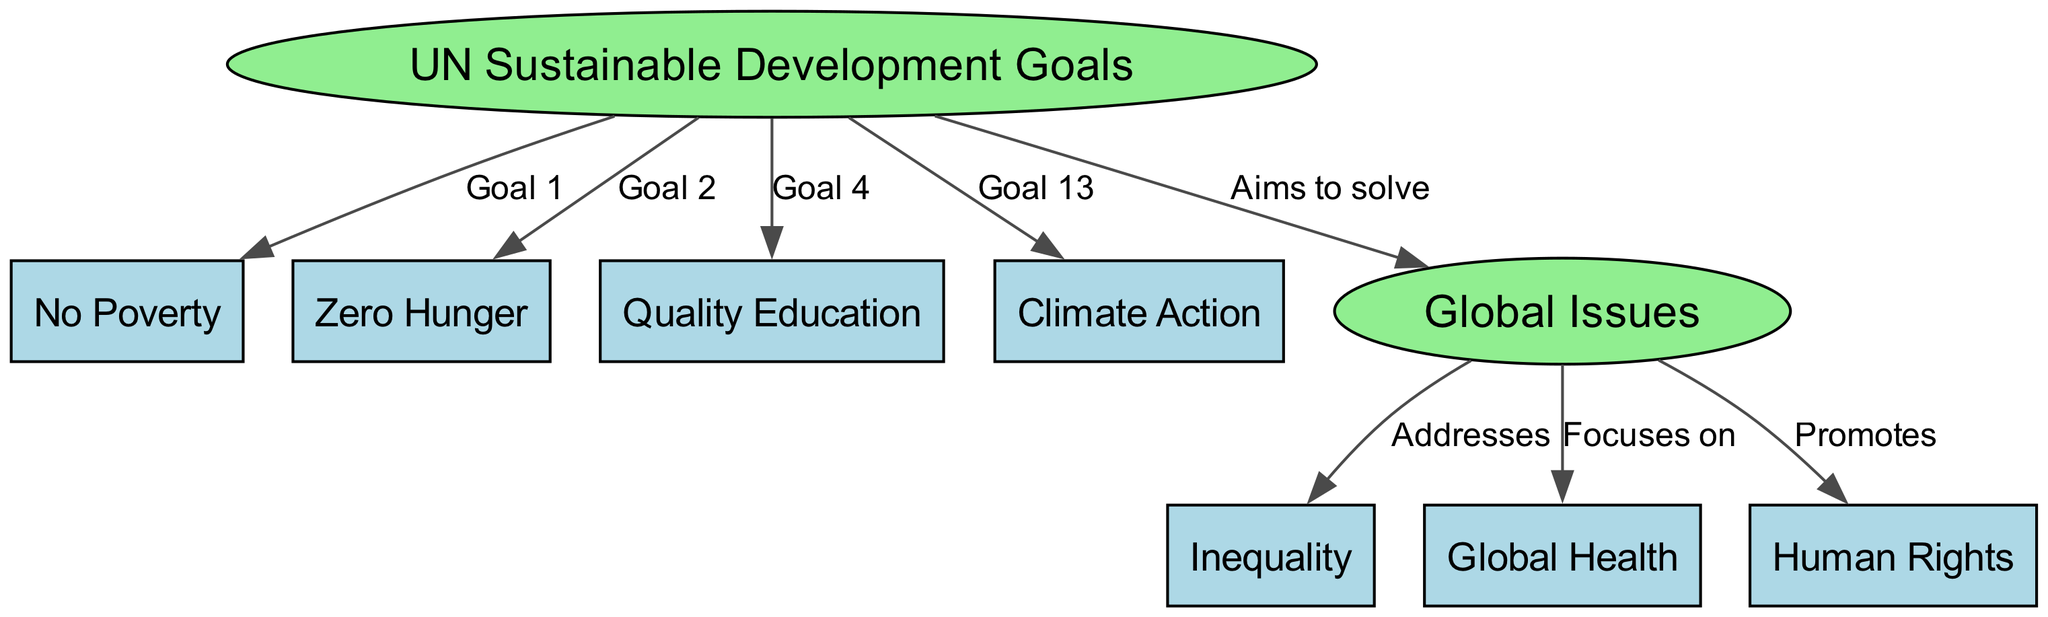What are the four main Sustainable Development Goals represented in the diagram? The diagram shows four specific Sustainable Development Goals: No Poverty, Zero Hunger, Quality Education, and Climate Action. These are found as distinct nodes directly connected to the UN Sustainable Development Goals node.
Answer: No Poverty, Zero Hunger, Quality Education, Climate Action How many edges connect the SDGs to specific goals? In the diagram, there are four edges connecting the SDGs node to specific goals, representing the relationships between the main goal and the four listed goals.
Answer: 4 Which global issue is addressed by the UN Sustainable Development Goals? The relationship between the SDGs and global issues is shown with an edge labeled "Aims to solve," indicating that they are intended to tackle various global issues like inequality, health, and human rights.
Answer: Inequality What is the label for the edge connecting global issues to health? The edge that connects the global issues node to the health node is labeled "Focuses on," which clearly indicates the relationship.
Answer: Focuses on How many total nodes are in the diagram? The diagram contains a total of eight nodes: four for the Sustainable Development Goals, one for global issues, and three for specific global issues (inequality, health, human rights).
Answer: 8 What goal number is associated with Climate Action? The diagram indicates that Climate Action is associated with Goal 13, as it is labeled that way in the edge connecting the SDGs to this goal.
Answer: Goal 13 Which global issue does the diagram promote related to human rights? The diagram shows that the global issues node promotes human rights, indicating a supportive relationship between global issues and the protection or advocacy for human rights.
Answer: Human Rights What does the SDGs aim to solve in relation to global issues? The edge labeled "Aims to solve" illustrates that the SDGs are designed to address problems within the realm of global issues, which include addressing inequality, health, and human rights.
Answer: Global Issues 